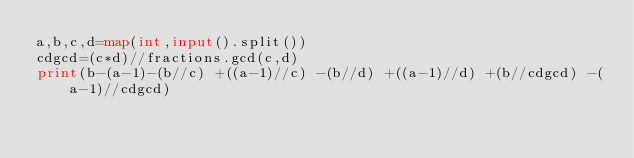<code> <loc_0><loc_0><loc_500><loc_500><_Python_>a,b,c,d=map(int,input().split())
cdgcd=(c*d)//fractions.gcd(c,d)
print(b-(a-1)-(b//c) +((a-1)//c) -(b//d) +((a-1)//d) +(b//cdgcd) -(a-1)//cdgcd)</code> 